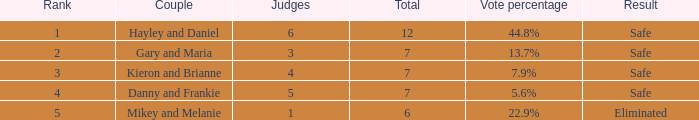What is the number of public that was there when the vote percentage was 22.9%? 1.0. 